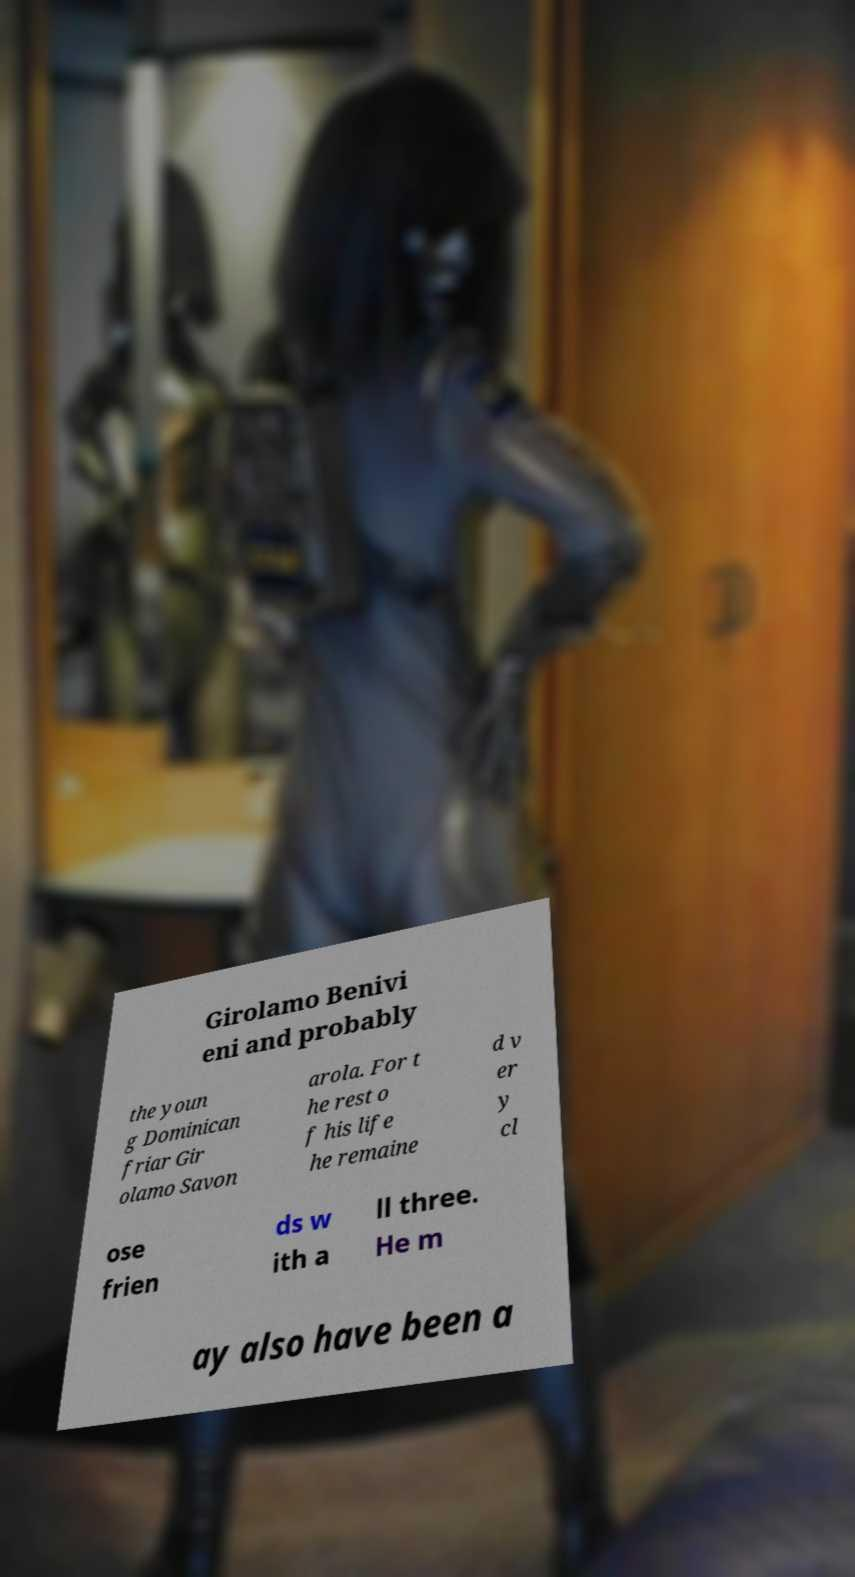For documentation purposes, I need the text within this image transcribed. Could you provide that? Girolamo Benivi eni and probably the youn g Dominican friar Gir olamo Savon arola. For t he rest o f his life he remaine d v er y cl ose frien ds w ith a ll three. He m ay also have been a 